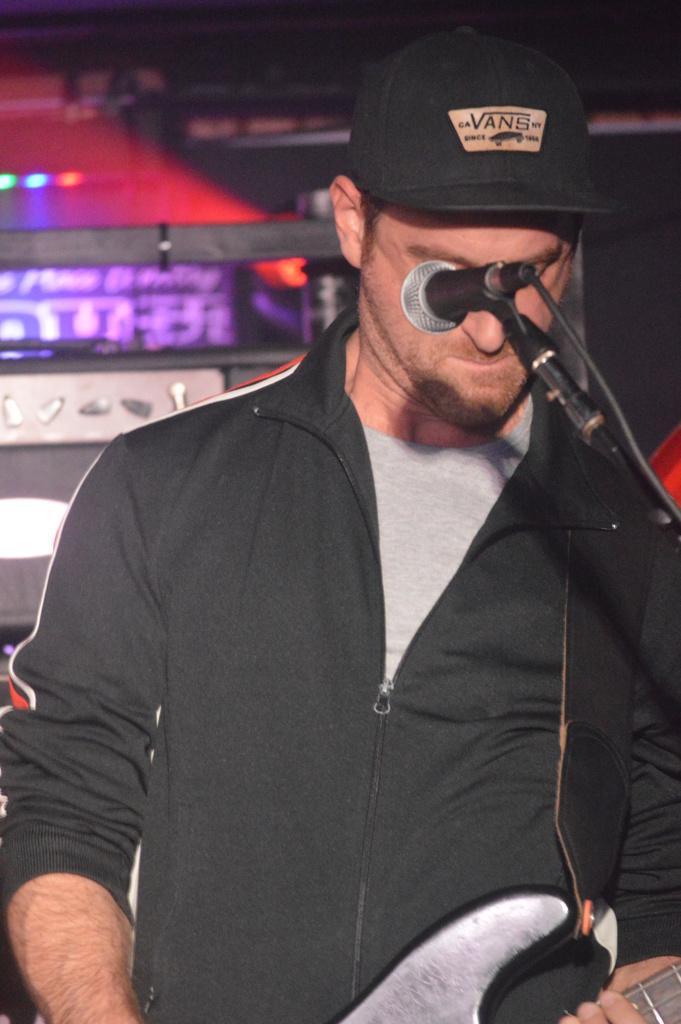Describe this image in one or two sentences. Here a man is playing guitar behind microphone. 